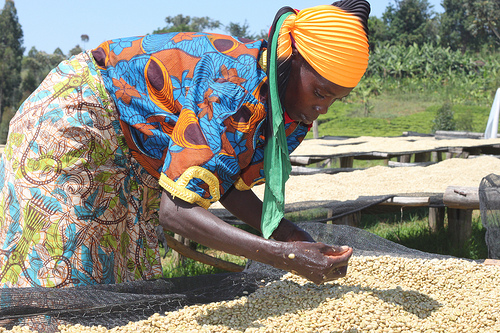<image>
Can you confirm if the stone is behind the person? Yes. From this viewpoint, the stone is positioned behind the person, with the person partially or fully occluding the stone. 